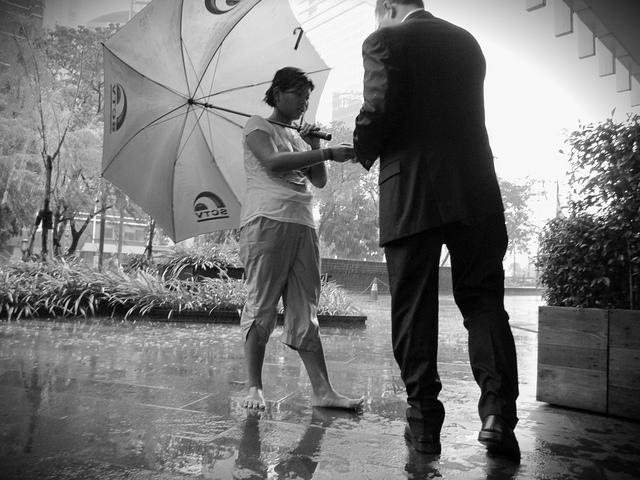What is she giving the man?

Choices:
A) water
B) drugs
C) change
D) food change 